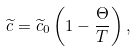<formula> <loc_0><loc_0><loc_500><loc_500>\widetilde { c } = \widetilde { c } _ { 0 } \left ( 1 - \frac { \Theta } { T } \right ) ,</formula> 